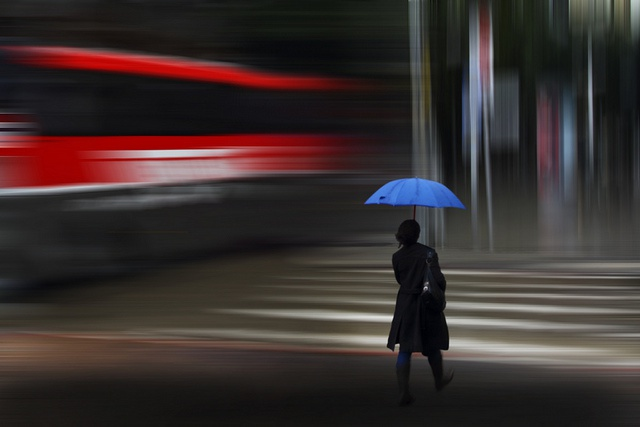Describe the objects in this image and their specific colors. I can see train in black, brown, maroon, and gray tones, people in black, gray, and darkgray tones, umbrella in black, gray, and blue tones, and handbag in black and gray tones in this image. 